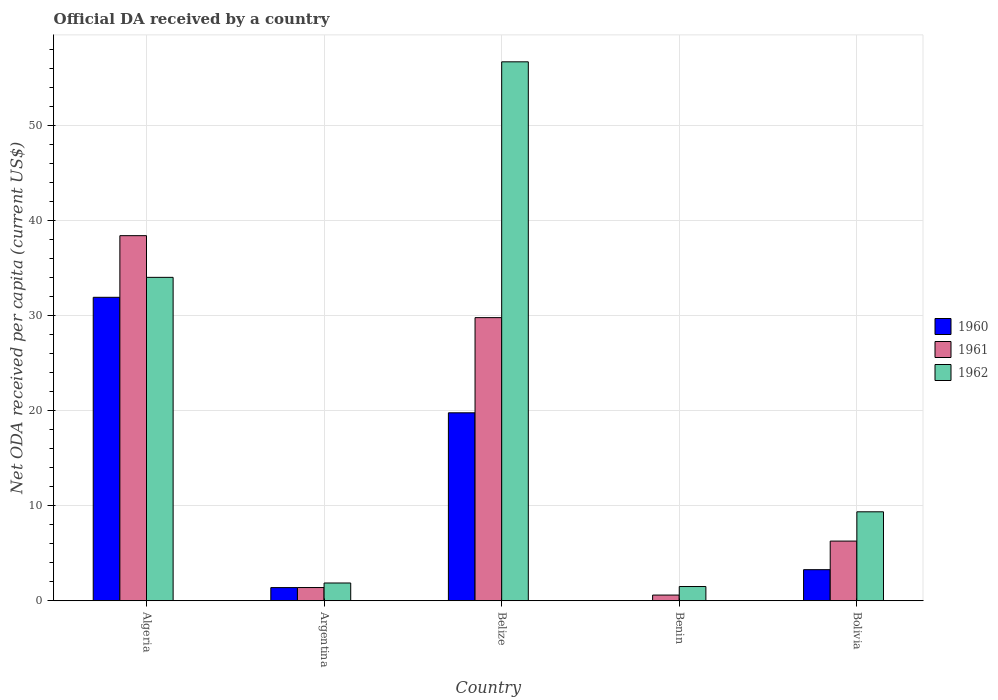How many different coloured bars are there?
Provide a short and direct response. 3. How many groups of bars are there?
Your answer should be compact. 5. How many bars are there on the 3rd tick from the left?
Give a very brief answer. 3. How many bars are there on the 4th tick from the right?
Your answer should be compact. 3. What is the label of the 1st group of bars from the left?
Your response must be concise. Algeria. In how many cases, is the number of bars for a given country not equal to the number of legend labels?
Offer a very short reply. 0. What is the ODA received in in 1962 in Belize?
Make the answer very short. 56.68. Across all countries, what is the maximum ODA received in in 1961?
Provide a succinct answer. 38.4. Across all countries, what is the minimum ODA received in in 1961?
Provide a succinct answer. 0.6. In which country was the ODA received in in 1961 maximum?
Make the answer very short. Algeria. In which country was the ODA received in in 1960 minimum?
Your answer should be very brief. Benin. What is the total ODA received in in 1960 in the graph?
Make the answer very short. 56.35. What is the difference between the ODA received in in 1962 in Algeria and that in Argentina?
Offer a very short reply. 32.14. What is the difference between the ODA received in in 1961 in Algeria and the ODA received in in 1960 in Argentina?
Make the answer very short. 37.01. What is the average ODA received in in 1962 per country?
Make the answer very short. 20.68. What is the difference between the ODA received in of/in 1962 and ODA received in of/in 1961 in Argentina?
Provide a succinct answer. 0.48. What is the ratio of the ODA received in in 1960 in Argentina to that in Bolivia?
Your response must be concise. 0.42. What is the difference between the highest and the second highest ODA received in in 1960?
Keep it short and to the point. -16.5. What is the difference between the highest and the lowest ODA received in in 1960?
Your answer should be compact. 31.91. What does the 1st bar from the left in Bolivia represents?
Give a very brief answer. 1960. What does the 2nd bar from the right in Argentina represents?
Provide a succinct answer. 1961. Is it the case that in every country, the sum of the ODA received in in 1962 and ODA received in in 1961 is greater than the ODA received in in 1960?
Your answer should be very brief. Yes. How many countries are there in the graph?
Your answer should be very brief. 5. Are the values on the major ticks of Y-axis written in scientific E-notation?
Make the answer very short. No. Does the graph contain any zero values?
Your response must be concise. No. Does the graph contain grids?
Your answer should be compact. Yes. Where does the legend appear in the graph?
Ensure brevity in your answer.  Center right. How many legend labels are there?
Offer a terse response. 3. How are the legend labels stacked?
Provide a short and direct response. Vertical. What is the title of the graph?
Provide a succinct answer. Official DA received by a country. What is the label or title of the X-axis?
Provide a succinct answer. Country. What is the label or title of the Y-axis?
Offer a very short reply. Net ODA received per capita (current US$). What is the Net ODA received per capita (current US$) in 1960 in Algeria?
Provide a succinct answer. 31.91. What is the Net ODA received per capita (current US$) of 1961 in Algeria?
Ensure brevity in your answer.  38.4. What is the Net ODA received per capita (current US$) in 1962 in Algeria?
Provide a succinct answer. 34.01. What is the Net ODA received per capita (current US$) in 1960 in Argentina?
Provide a succinct answer. 1.39. What is the Net ODA received per capita (current US$) of 1961 in Argentina?
Ensure brevity in your answer.  1.39. What is the Net ODA received per capita (current US$) of 1962 in Argentina?
Offer a very short reply. 1.87. What is the Net ODA received per capita (current US$) in 1960 in Belize?
Keep it short and to the point. 19.77. What is the Net ODA received per capita (current US$) of 1961 in Belize?
Your answer should be very brief. 29.78. What is the Net ODA received per capita (current US$) of 1962 in Belize?
Keep it short and to the point. 56.68. What is the Net ODA received per capita (current US$) in 1960 in Benin?
Ensure brevity in your answer.  0.01. What is the Net ODA received per capita (current US$) in 1961 in Benin?
Your answer should be very brief. 0.6. What is the Net ODA received per capita (current US$) of 1962 in Benin?
Offer a very short reply. 1.5. What is the Net ODA received per capita (current US$) in 1960 in Bolivia?
Provide a short and direct response. 3.27. What is the Net ODA received per capita (current US$) of 1961 in Bolivia?
Provide a succinct answer. 6.28. What is the Net ODA received per capita (current US$) of 1962 in Bolivia?
Your answer should be compact. 9.36. Across all countries, what is the maximum Net ODA received per capita (current US$) of 1960?
Your answer should be very brief. 31.91. Across all countries, what is the maximum Net ODA received per capita (current US$) of 1961?
Your answer should be compact. 38.4. Across all countries, what is the maximum Net ODA received per capita (current US$) of 1962?
Offer a very short reply. 56.68. Across all countries, what is the minimum Net ODA received per capita (current US$) of 1960?
Ensure brevity in your answer.  0.01. Across all countries, what is the minimum Net ODA received per capita (current US$) of 1961?
Keep it short and to the point. 0.6. Across all countries, what is the minimum Net ODA received per capita (current US$) of 1962?
Offer a terse response. 1.5. What is the total Net ODA received per capita (current US$) in 1960 in the graph?
Give a very brief answer. 56.35. What is the total Net ODA received per capita (current US$) of 1961 in the graph?
Make the answer very short. 76.44. What is the total Net ODA received per capita (current US$) of 1962 in the graph?
Provide a succinct answer. 103.42. What is the difference between the Net ODA received per capita (current US$) of 1960 in Algeria and that in Argentina?
Offer a terse response. 30.53. What is the difference between the Net ODA received per capita (current US$) of 1961 in Algeria and that in Argentina?
Provide a succinct answer. 37. What is the difference between the Net ODA received per capita (current US$) in 1962 in Algeria and that in Argentina?
Offer a terse response. 32.14. What is the difference between the Net ODA received per capita (current US$) of 1960 in Algeria and that in Belize?
Offer a terse response. 12.15. What is the difference between the Net ODA received per capita (current US$) in 1961 in Algeria and that in Belize?
Provide a short and direct response. 8.62. What is the difference between the Net ODA received per capita (current US$) of 1962 in Algeria and that in Belize?
Make the answer very short. -22.67. What is the difference between the Net ODA received per capita (current US$) in 1960 in Algeria and that in Benin?
Your answer should be compact. 31.91. What is the difference between the Net ODA received per capita (current US$) of 1961 in Algeria and that in Benin?
Provide a short and direct response. 37.8. What is the difference between the Net ODA received per capita (current US$) of 1962 in Algeria and that in Benin?
Ensure brevity in your answer.  32.52. What is the difference between the Net ODA received per capita (current US$) of 1960 in Algeria and that in Bolivia?
Offer a very short reply. 28.64. What is the difference between the Net ODA received per capita (current US$) of 1961 in Algeria and that in Bolivia?
Provide a short and direct response. 32.12. What is the difference between the Net ODA received per capita (current US$) in 1962 in Algeria and that in Bolivia?
Give a very brief answer. 24.66. What is the difference between the Net ODA received per capita (current US$) in 1960 in Argentina and that in Belize?
Provide a succinct answer. -18.38. What is the difference between the Net ODA received per capita (current US$) of 1961 in Argentina and that in Belize?
Offer a very short reply. -28.39. What is the difference between the Net ODA received per capita (current US$) of 1962 in Argentina and that in Belize?
Give a very brief answer. -54.81. What is the difference between the Net ODA received per capita (current US$) of 1960 in Argentina and that in Benin?
Provide a short and direct response. 1.38. What is the difference between the Net ODA received per capita (current US$) of 1961 in Argentina and that in Benin?
Your answer should be very brief. 0.79. What is the difference between the Net ODA received per capita (current US$) in 1962 in Argentina and that in Benin?
Keep it short and to the point. 0.37. What is the difference between the Net ODA received per capita (current US$) of 1960 in Argentina and that in Bolivia?
Ensure brevity in your answer.  -1.88. What is the difference between the Net ODA received per capita (current US$) of 1961 in Argentina and that in Bolivia?
Your response must be concise. -4.88. What is the difference between the Net ODA received per capita (current US$) in 1962 in Argentina and that in Bolivia?
Offer a very short reply. -7.49. What is the difference between the Net ODA received per capita (current US$) of 1960 in Belize and that in Benin?
Keep it short and to the point. 19.76. What is the difference between the Net ODA received per capita (current US$) of 1961 in Belize and that in Benin?
Keep it short and to the point. 29.18. What is the difference between the Net ODA received per capita (current US$) of 1962 in Belize and that in Benin?
Your answer should be very brief. 55.18. What is the difference between the Net ODA received per capita (current US$) of 1960 in Belize and that in Bolivia?
Provide a succinct answer. 16.5. What is the difference between the Net ODA received per capita (current US$) of 1961 in Belize and that in Bolivia?
Keep it short and to the point. 23.5. What is the difference between the Net ODA received per capita (current US$) of 1962 in Belize and that in Bolivia?
Keep it short and to the point. 47.32. What is the difference between the Net ODA received per capita (current US$) of 1960 in Benin and that in Bolivia?
Provide a short and direct response. -3.26. What is the difference between the Net ODA received per capita (current US$) of 1961 in Benin and that in Bolivia?
Give a very brief answer. -5.68. What is the difference between the Net ODA received per capita (current US$) of 1962 in Benin and that in Bolivia?
Ensure brevity in your answer.  -7.86. What is the difference between the Net ODA received per capita (current US$) in 1960 in Algeria and the Net ODA received per capita (current US$) in 1961 in Argentina?
Offer a terse response. 30.52. What is the difference between the Net ODA received per capita (current US$) of 1960 in Algeria and the Net ODA received per capita (current US$) of 1962 in Argentina?
Ensure brevity in your answer.  30.05. What is the difference between the Net ODA received per capita (current US$) in 1961 in Algeria and the Net ODA received per capita (current US$) in 1962 in Argentina?
Keep it short and to the point. 36.53. What is the difference between the Net ODA received per capita (current US$) of 1960 in Algeria and the Net ODA received per capita (current US$) of 1961 in Belize?
Provide a short and direct response. 2.14. What is the difference between the Net ODA received per capita (current US$) in 1960 in Algeria and the Net ODA received per capita (current US$) in 1962 in Belize?
Your answer should be compact. -24.77. What is the difference between the Net ODA received per capita (current US$) of 1961 in Algeria and the Net ODA received per capita (current US$) of 1962 in Belize?
Offer a very short reply. -18.28. What is the difference between the Net ODA received per capita (current US$) of 1960 in Algeria and the Net ODA received per capita (current US$) of 1961 in Benin?
Keep it short and to the point. 31.31. What is the difference between the Net ODA received per capita (current US$) in 1960 in Algeria and the Net ODA received per capita (current US$) in 1962 in Benin?
Provide a short and direct response. 30.42. What is the difference between the Net ODA received per capita (current US$) of 1961 in Algeria and the Net ODA received per capita (current US$) of 1962 in Benin?
Offer a very short reply. 36.9. What is the difference between the Net ODA received per capita (current US$) of 1960 in Algeria and the Net ODA received per capita (current US$) of 1961 in Bolivia?
Offer a very short reply. 25.64. What is the difference between the Net ODA received per capita (current US$) of 1960 in Algeria and the Net ODA received per capita (current US$) of 1962 in Bolivia?
Provide a succinct answer. 22.56. What is the difference between the Net ODA received per capita (current US$) in 1961 in Algeria and the Net ODA received per capita (current US$) in 1962 in Bolivia?
Make the answer very short. 29.04. What is the difference between the Net ODA received per capita (current US$) of 1960 in Argentina and the Net ODA received per capita (current US$) of 1961 in Belize?
Offer a terse response. -28.39. What is the difference between the Net ODA received per capita (current US$) of 1960 in Argentina and the Net ODA received per capita (current US$) of 1962 in Belize?
Ensure brevity in your answer.  -55.29. What is the difference between the Net ODA received per capita (current US$) of 1961 in Argentina and the Net ODA received per capita (current US$) of 1962 in Belize?
Your answer should be compact. -55.29. What is the difference between the Net ODA received per capita (current US$) in 1960 in Argentina and the Net ODA received per capita (current US$) in 1961 in Benin?
Provide a short and direct response. 0.79. What is the difference between the Net ODA received per capita (current US$) in 1960 in Argentina and the Net ODA received per capita (current US$) in 1962 in Benin?
Your answer should be very brief. -0.11. What is the difference between the Net ODA received per capita (current US$) of 1961 in Argentina and the Net ODA received per capita (current US$) of 1962 in Benin?
Offer a terse response. -0.11. What is the difference between the Net ODA received per capita (current US$) of 1960 in Argentina and the Net ODA received per capita (current US$) of 1961 in Bolivia?
Your response must be concise. -4.89. What is the difference between the Net ODA received per capita (current US$) in 1960 in Argentina and the Net ODA received per capita (current US$) in 1962 in Bolivia?
Provide a short and direct response. -7.97. What is the difference between the Net ODA received per capita (current US$) of 1961 in Argentina and the Net ODA received per capita (current US$) of 1962 in Bolivia?
Keep it short and to the point. -7.96. What is the difference between the Net ODA received per capita (current US$) of 1960 in Belize and the Net ODA received per capita (current US$) of 1961 in Benin?
Your response must be concise. 19.17. What is the difference between the Net ODA received per capita (current US$) of 1960 in Belize and the Net ODA received per capita (current US$) of 1962 in Benin?
Give a very brief answer. 18.27. What is the difference between the Net ODA received per capita (current US$) in 1961 in Belize and the Net ODA received per capita (current US$) in 1962 in Benin?
Your response must be concise. 28.28. What is the difference between the Net ODA received per capita (current US$) of 1960 in Belize and the Net ODA received per capita (current US$) of 1961 in Bolivia?
Your answer should be very brief. 13.49. What is the difference between the Net ODA received per capita (current US$) of 1960 in Belize and the Net ODA received per capita (current US$) of 1962 in Bolivia?
Make the answer very short. 10.41. What is the difference between the Net ODA received per capita (current US$) of 1961 in Belize and the Net ODA received per capita (current US$) of 1962 in Bolivia?
Your response must be concise. 20.42. What is the difference between the Net ODA received per capita (current US$) of 1960 in Benin and the Net ODA received per capita (current US$) of 1961 in Bolivia?
Offer a very short reply. -6.27. What is the difference between the Net ODA received per capita (current US$) of 1960 in Benin and the Net ODA received per capita (current US$) of 1962 in Bolivia?
Offer a very short reply. -9.35. What is the difference between the Net ODA received per capita (current US$) in 1961 in Benin and the Net ODA received per capita (current US$) in 1962 in Bolivia?
Provide a succinct answer. -8.76. What is the average Net ODA received per capita (current US$) of 1960 per country?
Give a very brief answer. 11.27. What is the average Net ODA received per capita (current US$) of 1961 per country?
Provide a succinct answer. 15.29. What is the average Net ODA received per capita (current US$) of 1962 per country?
Make the answer very short. 20.68. What is the difference between the Net ODA received per capita (current US$) in 1960 and Net ODA received per capita (current US$) in 1961 in Algeria?
Your response must be concise. -6.48. What is the difference between the Net ODA received per capita (current US$) in 1960 and Net ODA received per capita (current US$) in 1962 in Algeria?
Give a very brief answer. -2.1. What is the difference between the Net ODA received per capita (current US$) of 1961 and Net ODA received per capita (current US$) of 1962 in Algeria?
Provide a succinct answer. 4.38. What is the difference between the Net ODA received per capita (current US$) of 1960 and Net ODA received per capita (current US$) of 1961 in Argentina?
Offer a terse response. -0.01. What is the difference between the Net ODA received per capita (current US$) in 1960 and Net ODA received per capita (current US$) in 1962 in Argentina?
Offer a very short reply. -0.48. What is the difference between the Net ODA received per capita (current US$) of 1961 and Net ODA received per capita (current US$) of 1962 in Argentina?
Offer a very short reply. -0.48. What is the difference between the Net ODA received per capita (current US$) of 1960 and Net ODA received per capita (current US$) of 1961 in Belize?
Provide a succinct answer. -10.01. What is the difference between the Net ODA received per capita (current US$) of 1960 and Net ODA received per capita (current US$) of 1962 in Belize?
Your answer should be very brief. -36.91. What is the difference between the Net ODA received per capita (current US$) of 1961 and Net ODA received per capita (current US$) of 1962 in Belize?
Provide a short and direct response. -26.9. What is the difference between the Net ODA received per capita (current US$) of 1960 and Net ODA received per capita (current US$) of 1961 in Benin?
Provide a succinct answer. -0.59. What is the difference between the Net ODA received per capita (current US$) in 1960 and Net ODA received per capita (current US$) in 1962 in Benin?
Provide a short and direct response. -1.49. What is the difference between the Net ODA received per capita (current US$) in 1961 and Net ODA received per capita (current US$) in 1962 in Benin?
Keep it short and to the point. -0.9. What is the difference between the Net ODA received per capita (current US$) in 1960 and Net ODA received per capita (current US$) in 1961 in Bolivia?
Offer a terse response. -3.01. What is the difference between the Net ODA received per capita (current US$) in 1960 and Net ODA received per capita (current US$) in 1962 in Bolivia?
Keep it short and to the point. -6.09. What is the difference between the Net ODA received per capita (current US$) in 1961 and Net ODA received per capita (current US$) in 1962 in Bolivia?
Keep it short and to the point. -3.08. What is the ratio of the Net ODA received per capita (current US$) in 1960 in Algeria to that in Argentina?
Ensure brevity in your answer.  23.03. What is the ratio of the Net ODA received per capita (current US$) of 1961 in Algeria to that in Argentina?
Make the answer very short. 27.57. What is the ratio of the Net ODA received per capita (current US$) in 1962 in Algeria to that in Argentina?
Your answer should be compact. 18.19. What is the ratio of the Net ODA received per capita (current US$) of 1960 in Algeria to that in Belize?
Provide a short and direct response. 1.61. What is the ratio of the Net ODA received per capita (current US$) of 1961 in Algeria to that in Belize?
Give a very brief answer. 1.29. What is the ratio of the Net ODA received per capita (current US$) of 1962 in Algeria to that in Belize?
Make the answer very short. 0.6. What is the ratio of the Net ODA received per capita (current US$) of 1960 in Algeria to that in Benin?
Offer a terse response. 3880.25. What is the ratio of the Net ODA received per capita (current US$) of 1961 in Algeria to that in Benin?
Offer a terse response. 63.98. What is the ratio of the Net ODA received per capita (current US$) of 1962 in Algeria to that in Benin?
Keep it short and to the point. 22.71. What is the ratio of the Net ODA received per capita (current US$) in 1960 in Algeria to that in Bolivia?
Your response must be concise. 9.76. What is the ratio of the Net ODA received per capita (current US$) of 1961 in Algeria to that in Bolivia?
Offer a terse response. 6.12. What is the ratio of the Net ODA received per capita (current US$) of 1962 in Algeria to that in Bolivia?
Make the answer very short. 3.64. What is the ratio of the Net ODA received per capita (current US$) of 1960 in Argentina to that in Belize?
Your answer should be compact. 0.07. What is the ratio of the Net ODA received per capita (current US$) of 1961 in Argentina to that in Belize?
Provide a succinct answer. 0.05. What is the ratio of the Net ODA received per capita (current US$) of 1962 in Argentina to that in Belize?
Provide a short and direct response. 0.03. What is the ratio of the Net ODA received per capita (current US$) of 1960 in Argentina to that in Benin?
Your answer should be compact. 168.52. What is the ratio of the Net ODA received per capita (current US$) of 1961 in Argentina to that in Benin?
Give a very brief answer. 2.32. What is the ratio of the Net ODA received per capita (current US$) of 1962 in Argentina to that in Benin?
Offer a very short reply. 1.25. What is the ratio of the Net ODA received per capita (current US$) in 1960 in Argentina to that in Bolivia?
Ensure brevity in your answer.  0.42. What is the ratio of the Net ODA received per capita (current US$) of 1961 in Argentina to that in Bolivia?
Give a very brief answer. 0.22. What is the ratio of the Net ODA received per capita (current US$) in 1962 in Argentina to that in Bolivia?
Keep it short and to the point. 0.2. What is the ratio of the Net ODA received per capita (current US$) in 1960 in Belize to that in Benin?
Provide a succinct answer. 2403.41. What is the ratio of the Net ODA received per capita (current US$) in 1961 in Belize to that in Benin?
Offer a very short reply. 49.62. What is the ratio of the Net ODA received per capita (current US$) of 1962 in Belize to that in Benin?
Give a very brief answer. 37.84. What is the ratio of the Net ODA received per capita (current US$) of 1960 in Belize to that in Bolivia?
Your response must be concise. 6.04. What is the ratio of the Net ODA received per capita (current US$) of 1961 in Belize to that in Bolivia?
Your answer should be compact. 4.74. What is the ratio of the Net ODA received per capita (current US$) in 1962 in Belize to that in Bolivia?
Keep it short and to the point. 6.06. What is the ratio of the Net ODA received per capita (current US$) in 1960 in Benin to that in Bolivia?
Provide a succinct answer. 0. What is the ratio of the Net ODA received per capita (current US$) of 1961 in Benin to that in Bolivia?
Provide a succinct answer. 0.1. What is the ratio of the Net ODA received per capita (current US$) in 1962 in Benin to that in Bolivia?
Your answer should be compact. 0.16. What is the difference between the highest and the second highest Net ODA received per capita (current US$) in 1960?
Your response must be concise. 12.15. What is the difference between the highest and the second highest Net ODA received per capita (current US$) of 1961?
Offer a terse response. 8.62. What is the difference between the highest and the second highest Net ODA received per capita (current US$) in 1962?
Your answer should be very brief. 22.67. What is the difference between the highest and the lowest Net ODA received per capita (current US$) of 1960?
Make the answer very short. 31.91. What is the difference between the highest and the lowest Net ODA received per capita (current US$) of 1961?
Your answer should be very brief. 37.8. What is the difference between the highest and the lowest Net ODA received per capita (current US$) in 1962?
Make the answer very short. 55.18. 